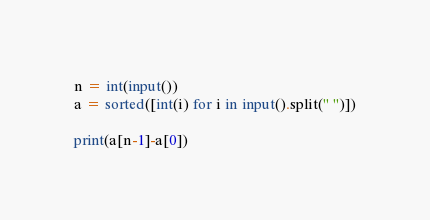Convert code to text. <code><loc_0><loc_0><loc_500><loc_500><_Python_>n = int(input())
a = sorted([int(i) for i in input().split(" ")])

print(a[n-1]-a[0])</code> 